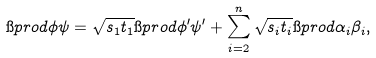Convert formula to latex. <formula><loc_0><loc_0><loc_500><loc_500>\i p r o d { \phi } { \psi } = \sqrt { s _ { 1 } t _ { 1 } } \i p r o d { \phi ^ { \prime } } { \psi ^ { \prime } } + \sum _ { i = 2 } ^ { n } \sqrt { s _ { i } t _ { i } } \i p r o d { \alpha _ { i } } { \beta _ { i } } ,</formula> 